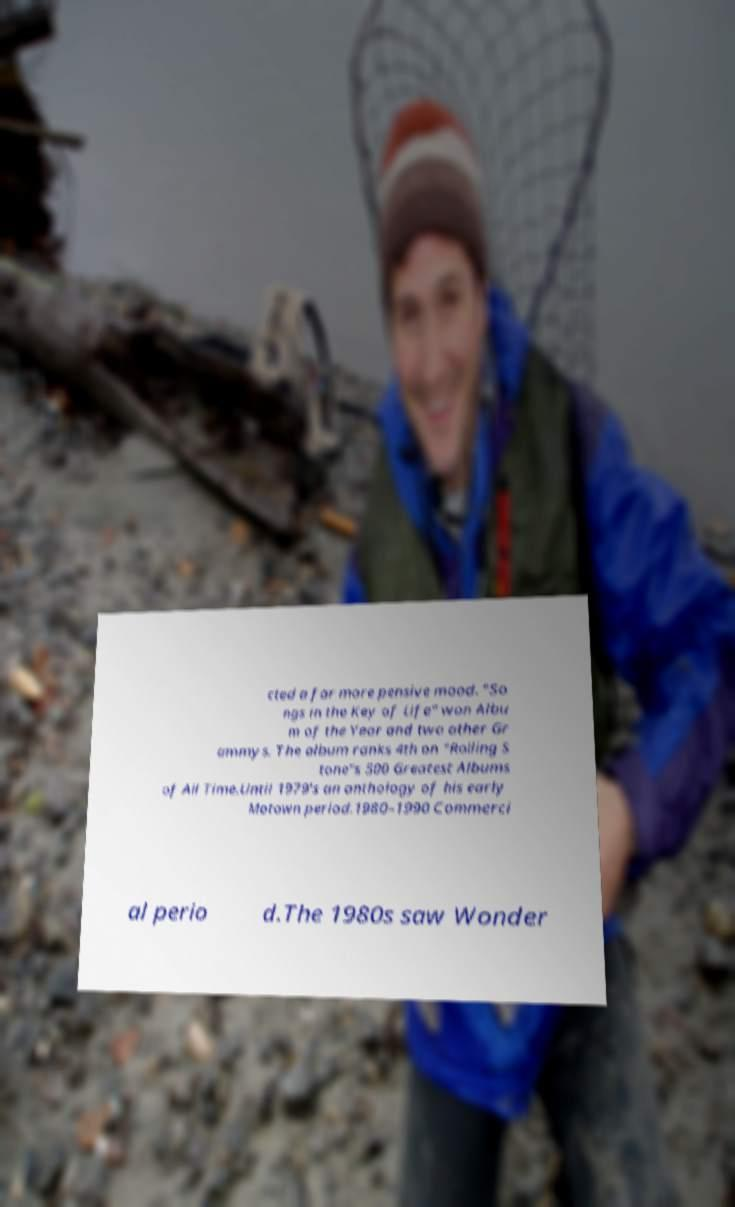Could you assist in decoding the text presented in this image and type it out clearly? cted a far more pensive mood. "So ngs in the Key of Life" won Albu m of the Year and two other Gr ammys. The album ranks 4th on "Rolling S tone"s 500 Greatest Albums of All Time.Until 1979's an anthology of his early Motown period.1980–1990 Commerci al perio d.The 1980s saw Wonder 